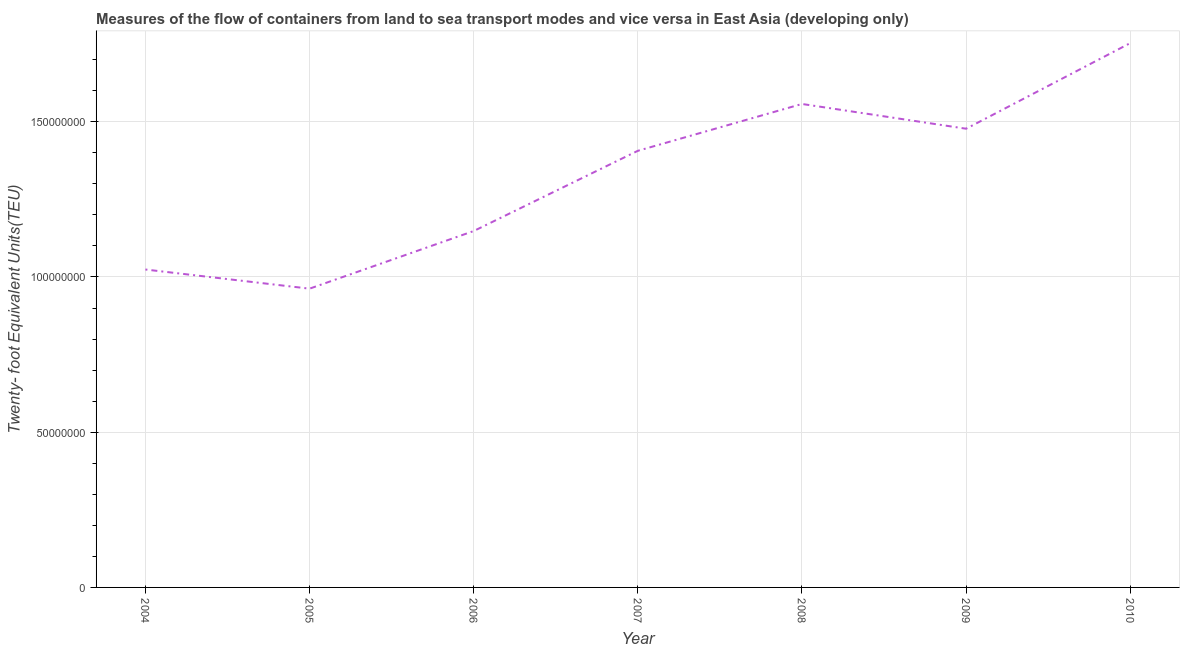What is the container port traffic in 2008?
Offer a very short reply. 1.56e+08. Across all years, what is the maximum container port traffic?
Offer a terse response. 1.75e+08. Across all years, what is the minimum container port traffic?
Keep it short and to the point. 9.62e+07. What is the sum of the container port traffic?
Keep it short and to the point. 9.33e+08. What is the difference between the container port traffic in 2005 and 2006?
Offer a very short reply. -1.86e+07. What is the average container port traffic per year?
Give a very brief answer. 1.33e+08. What is the median container port traffic?
Offer a very short reply. 1.41e+08. What is the ratio of the container port traffic in 2008 to that in 2009?
Provide a succinct answer. 1.05. Is the container port traffic in 2009 less than that in 2010?
Make the answer very short. Yes. Is the difference between the container port traffic in 2004 and 2005 greater than the difference between any two years?
Ensure brevity in your answer.  No. What is the difference between the highest and the second highest container port traffic?
Your answer should be compact. 1.96e+07. What is the difference between the highest and the lowest container port traffic?
Ensure brevity in your answer.  7.91e+07. How many lines are there?
Offer a terse response. 1. Are the values on the major ticks of Y-axis written in scientific E-notation?
Your answer should be very brief. No. What is the title of the graph?
Provide a short and direct response. Measures of the flow of containers from land to sea transport modes and vice versa in East Asia (developing only). What is the label or title of the X-axis?
Give a very brief answer. Year. What is the label or title of the Y-axis?
Make the answer very short. Twenty- foot Equivalent Units(TEU). What is the Twenty- foot Equivalent Units(TEU) of 2004?
Provide a short and direct response. 1.02e+08. What is the Twenty- foot Equivalent Units(TEU) of 2005?
Ensure brevity in your answer.  9.62e+07. What is the Twenty- foot Equivalent Units(TEU) of 2006?
Your answer should be very brief. 1.15e+08. What is the Twenty- foot Equivalent Units(TEU) of 2007?
Your answer should be very brief. 1.41e+08. What is the Twenty- foot Equivalent Units(TEU) of 2008?
Provide a short and direct response. 1.56e+08. What is the Twenty- foot Equivalent Units(TEU) of 2009?
Make the answer very short. 1.48e+08. What is the Twenty- foot Equivalent Units(TEU) in 2010?
Your response must be concise. 1.75e+08. What is the difference between the Twenty- foot Equivalent Units(TEU) in 2004 and 2005?
Provide a succinct answer. 6.17e+06. What is the difference between the Twenty- foot Equivalent Units(TEU) in 2004 and 2006?
Give a very brief answer. -1.24e+07. What is the difference between the Twenty- foot Equivalent Units(TEU) in 2004 and 2007?
Offer a terse response. -3.82e+07. What is the difference between the Twenty- foot Equivalent Units(TEU) in 2004 and 2008?
Make the answer very short. -5.33e+07. What is the difference between the Twenty- foot Equivalent Units(TEU) in 2004 and 2009?
Keep it short and to the point. -4.54e+07. What is the difference between the Twenty- foot Equivalent Units(TEU) in 2004 and 2010?
Make the answer very short. -7.29e+07. What is the difference between the Twenty- foot Equivalent Units(TEU) in 2005 and 2006?
Your response must be concise. -1.86e+07. What is the difference between the Twenty- foot Equivalent Units(TEU) in 2005 and 2007?
Offer a terse response. -4.44e+07. What is the difference between the Twenty- foot Equivalent Units(TEU) in 2005 and 2008?
Offer a terse response. -5.95e+07. What is the difference between the Twenty- foot Equivalent Units(TEU) in 2005 and 2009?
Offer a very short reply. -5.15e+07. What is the difference between the Twenty- foot Equivalent Units(TEU) in 2005 and 2010?
Your answer should be very brief. -7.91e+07. What is the difference between the Twenty- foot Equivalent Units(TEU) in 2006 and 2007?
Ensure brevity in your answer.  -2.58e+07. What is the difference between the Twenty- foot Equivalent Units(TEU) in 2006 and 2008?
Provide a short and direct response. -4.09e+07. What is the difference between the Twenty- foot Equivalent Units(TEU) in 2006 and 2009?
Make the answer very short. -3.30e+07. What is the difference between the Twenty- foot Equivalent Units(TEU) in 2006 and 2010?
Offer a terse response. -6.05e+07. What is the difference between the Twenty- foot Equivalent Units(TEU) in 2007 and 2008?
Provide a short and direct response. -1.51e+07. What is the difference between the Twenty- foot Equivalent Units(TEU) in 2007 and 2009?
Your answer should be compact. -7.11e+06. What is the difference between the Twenty- foot Equivalent Units(TEU) in 2007 and 2010?
Your answer should be very brief. -3.47e+07. What is the difference between the Twenty- foot Equivalent Units(TEU) in 2008 and 2009?
Offer a very short reply. 7.97e+06. What is the difference between the Twenty- foot Equivalent Units(TEU) in 2008 and 2010?
Provide a succinct answer. -1.96e+07. What is the difference between the Twenty- foot Equivalent Units(TEU) in 2009 and 2010?
Your response must be concise. -2.76e+07. What is the ratio of the Twenty- foot Equivalent Units(TEU) in 2004 to that in 2005?
Your answer should be compact. 1.06. What is the ratio of the Twenty- foot Equivalent Units(TEU) in 2004 to that in 2006?
Offer a terse response. 0.89. What is the ratio of the Twenty- foot Equivalent Units(TEU) in 2004 to that in 2007?
Your answer should be very brief. 0.73. What is the ratio of the Twenty- foot Equivalent Units(TEU) in 2004 to that in 2008?
Keep it short and to the point. 0.66. What is the ratio of the Twenty- foot Equivalent Units(TEU) in 2004 to that in 2009?
Keep it short and to the point. 0.69. What is the ratio of the Twenty- foot Equivalent Units(TEU) in 2004 to that in 2010?
Keep it short and to the point. 0.58. What is the ratio of the Twenty- foot Equivalent Units(TEU) in 2005 to that in 2006?
Offer a terse response. 0.84. What is the ratio of the Twenty- foot Equivalent Units(TEU) in 2005 to that in 2007?
Offer a very short reply. 0.68. What is the ratio of the Twenty- foot Equivalent Units(TEU) in 2005 to that in 2008?
Provide a short and direct response. 0.62. What is the ratio of the Twenty- foot Equivalent Units(TEU) in 2005 to that in 2009?
Offer a very short reply. 0.65. What is the ratio of the Twenty- foot Equivalent Units(TEU) in 2005 to that in 2010?
Provide a short and direct response. 0.55. What is the ratio of the Twenty- foot Equivalent Units(TEU) in 2006 to that in 2007?
Make the answer very short. 0.82. What is the ratio of the Twenty- foot Equivalent Units(TEU) in 2006 to that in 2008?
Keep it short and to the point. 0.74. What is the ratio of the Twenty- foot Equivalent Units(TEU) in 2006 to that in 2009?
Your answer should be compact. 0.78. What is the ratio of the Twenty- foot Equivalent Units(TEU) in 2006 to that in 2010?
Provide a succinct answer. 0.66. What is the ratio of the Twenty- foot Equivalent Units(TEU) in 2007 to that in 2008?
Offer a terse response. 0.9. What is the ratio of the Twenty- foot Equivalent Units(TEU) in 2007 to that in 2010?
Keep it short and to the point. 0.8. What is the ratio of the Twenty- foot Equivalent Units(TEU) in 2008 to that in 2009?
Provide a succinct answer. 1.05. What is the ratio of the Twenty- foot Equivalent Units(TEU) in 2008 to that in 2010?
Your answer should be compact. 0.89. What is the ratio of the Twenty- foot Equivalent Units(TEU) in 2009 to that in 2010?
Offer a very short reply. 0.84. 